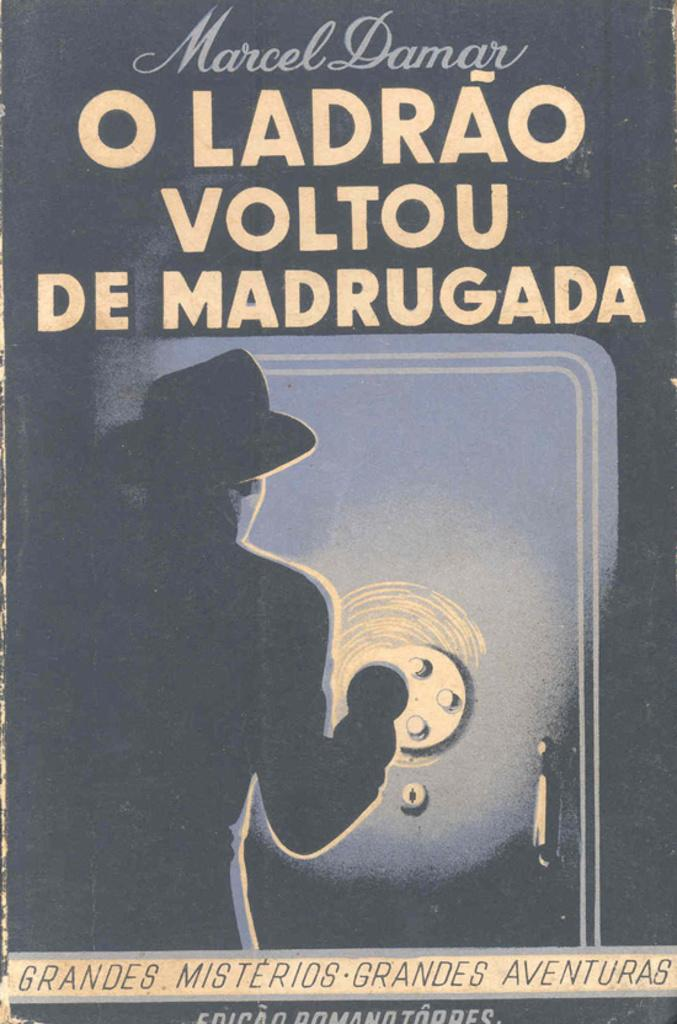<image>
Create a compact narrative representing the image presented. Vintage Poster advertisement for Marcel Damar O Ladrao Voltou de Madrugada with a man in fedora hat attempting to crack a safe. 